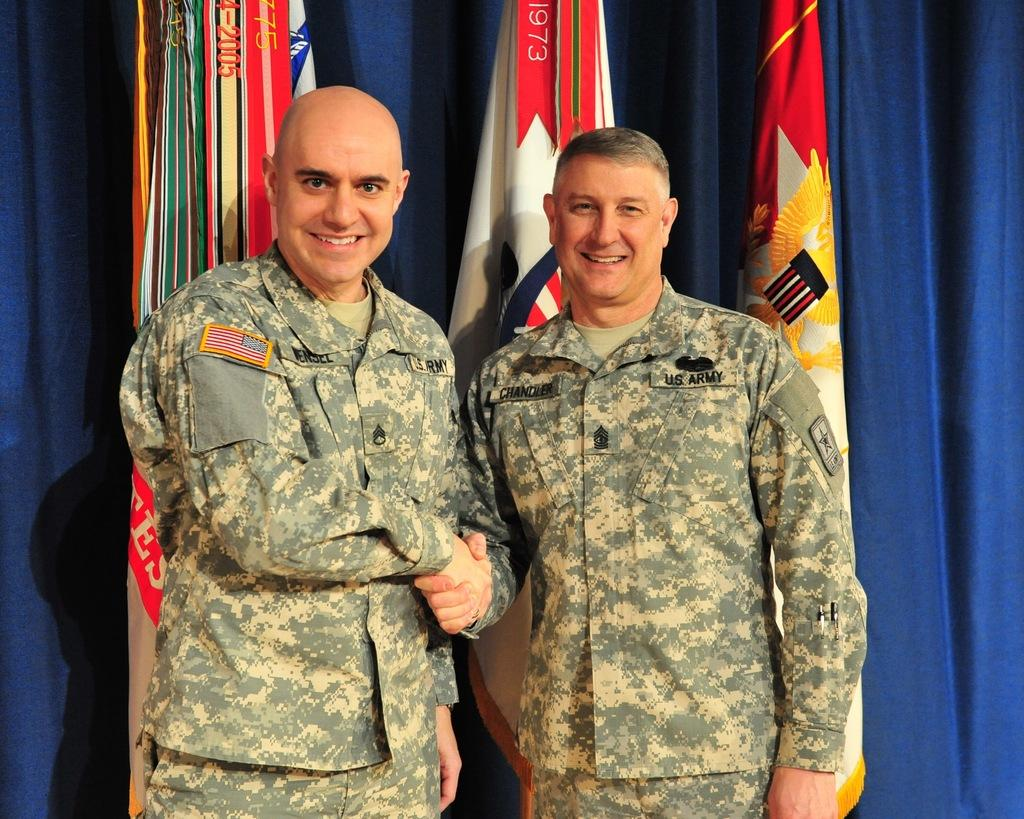Who is present in the image? There are men in the image. What are the men doing in the image? The men are shaking hands and smiling. What can be seen in the background of the image? There are flags and a blue curtain in the background of the image. What type of bottle is being used to recite a verse in the image? There is no bottle or verse present in the image; the men are shaking hands and smiling. 